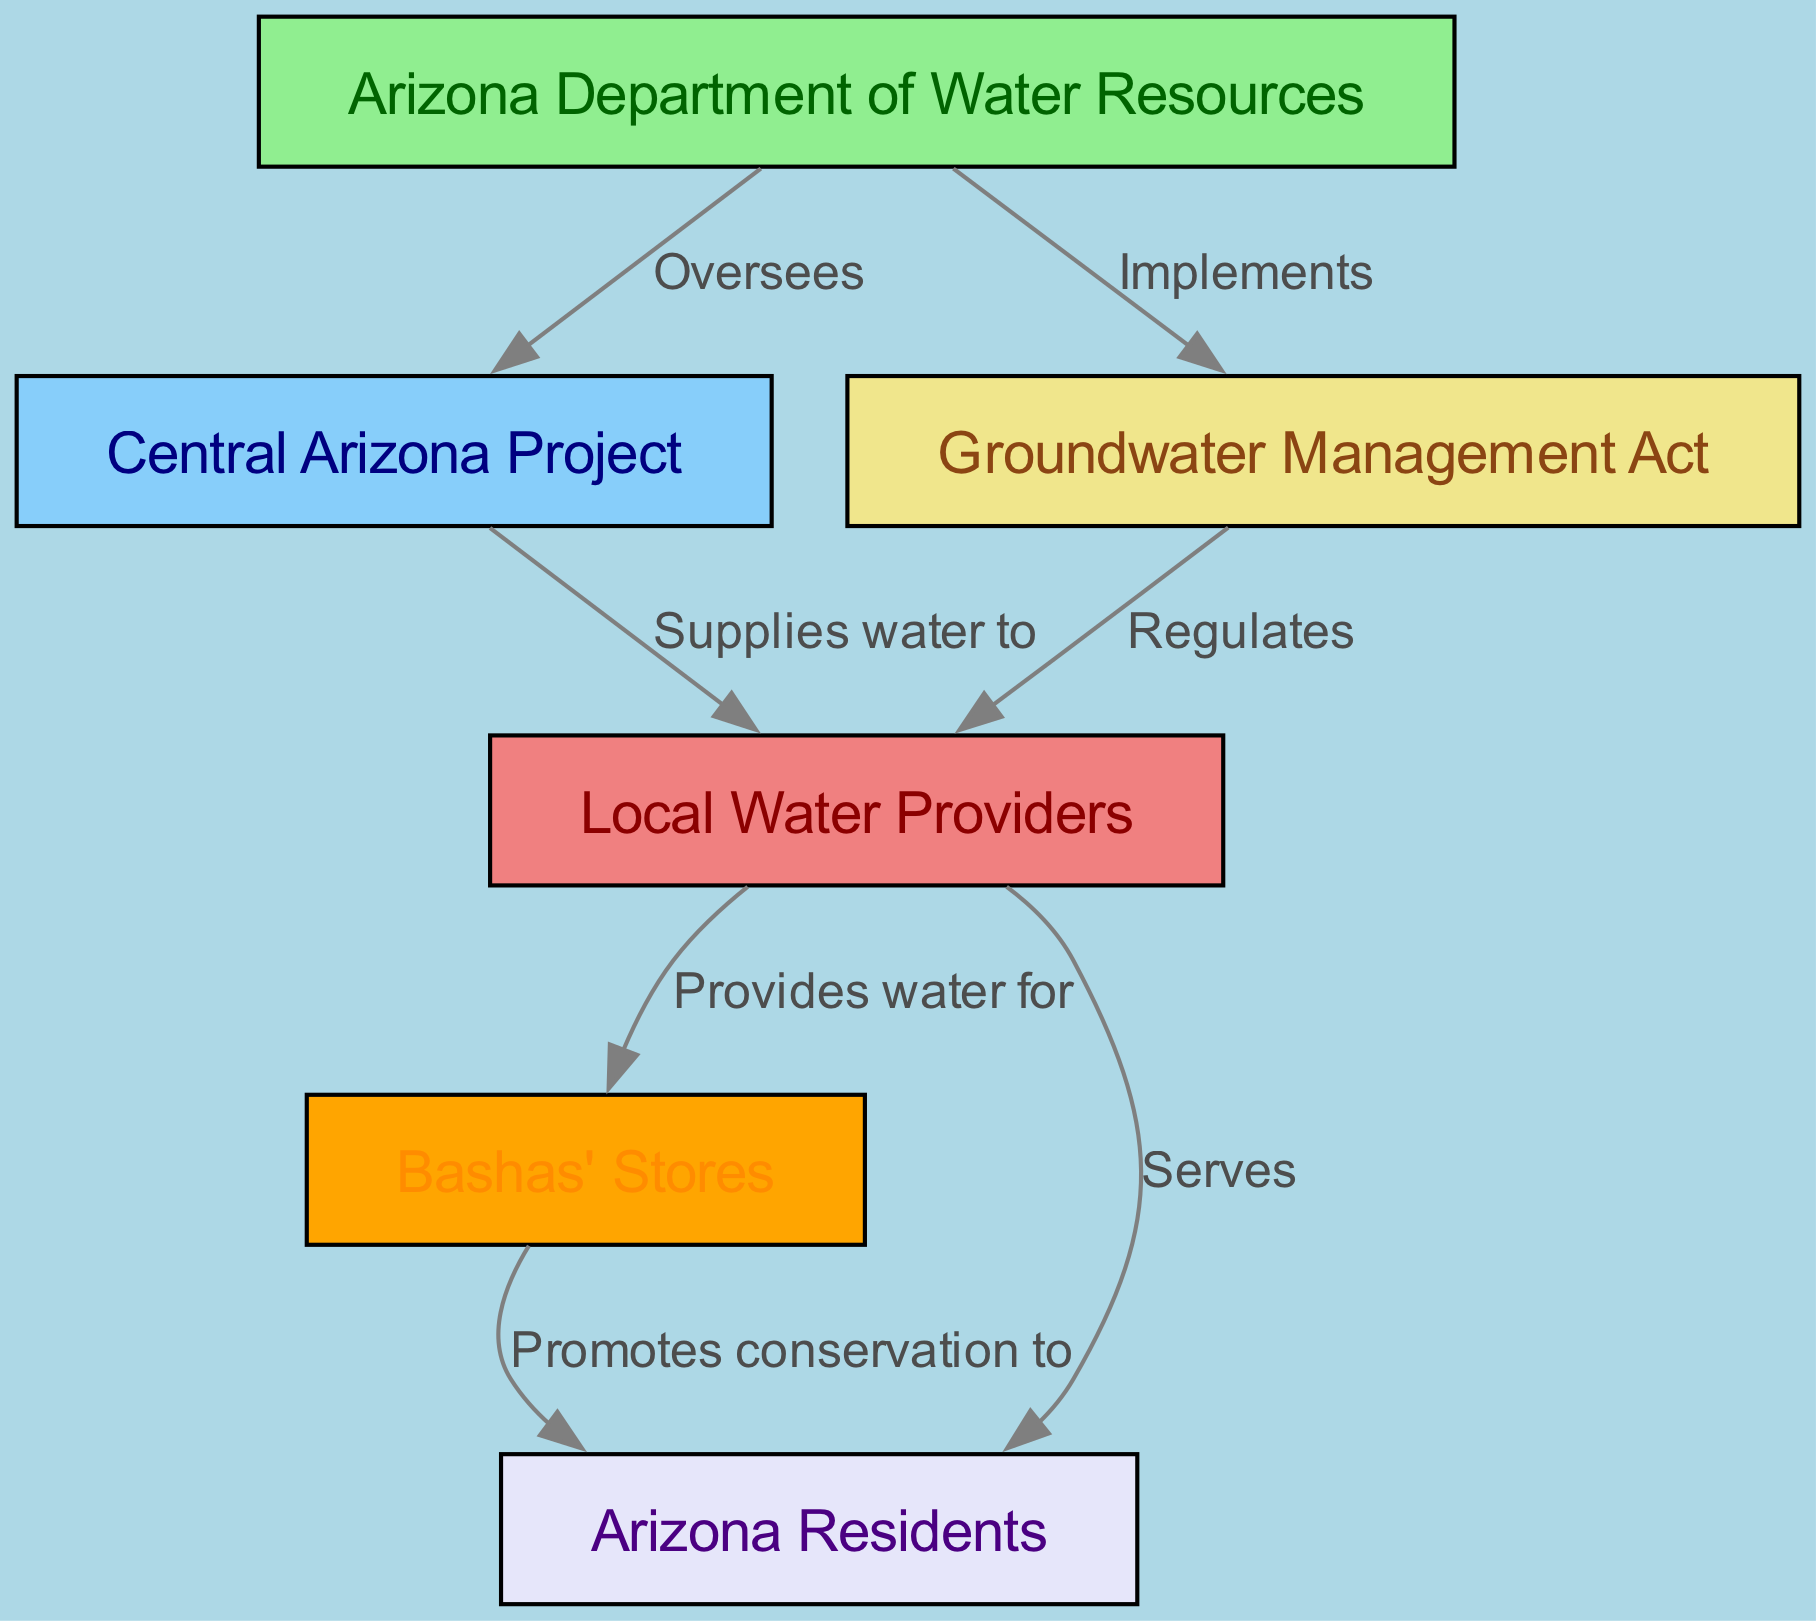What is the total number of nodes in the diagram? The diagram lists the following nodes: Arizona Department of Water Resources, Central Arizona Project, Groundwater Management Act, Local Water Providers, Bashas' Stores, and Arizona Residents. Counting these gives a total of six nodes.
Answer: 6 Which node oversees the Central Arizona Project? The diagram shows an edge from the Arizona Department of Water Resources to the Central Arizona Project labeled "Oversees." This indicates that the Arizona Department of Water Resources is the node responsible for overseeing the Central Arizona Project.
Answer: Arizona Department of Water Resources What label describes the relationship between the Central Arizona Project and Local Water Providers? The edge from the Central Arizona Project to Local Water Providers is labeled "Supplies water to," implying that the Central Arizona Project provides water to local water providers.
Answer: Supplies water to Who promotes conservation to Arizona Residents? According to the diagram, there is an edge from Bashas' Stores to Arizona Residents labeled "Promotes conservation to." This indicates that Bashas' Stores is the entity that promotes water conservation practices to the residents of Arizona.
Answer: Bashas' Stores How many edges are present in the diagram? The diagram has the following edges: Arizona Department of Water Resources to Central Arizona Project, Arizona Department of Water Resources to Groundwater Management Act, Central Arizona Project to Local Water Providers, Groundwater Management Act to Local Water Providers, Local Water Providers to Bashas' Stores, Local Water Providers to Arizona Residents, and Bashas' Stores to Arizona Residents. Counting these gives a total of seven edges.
Answer: 7 Which node is regulated by the Groundwater Management Act? The diagram indicates that the Groundwater Management Act has an edge pointing to Local Water Providers with the label "Regulates." This means that the Local Water Providers are the entities that are regulated by the Groundwater Management Act.
Answer: Local Water Providers What is the impact of Local Water Providers on Bashas' Stores? The edge from Local Water Providers to Bashas' Stores is labeled "Provides water for," indicating that the Local Water Providers supply water for Bashas' Stores, directly impacting their operations.
Answer: Provides water for What is the color associated with Arizona Department of Water Resources in the diagram? The Arizona Department of Water Resources is represented as a green node in the diagram, specifically light green, indicating its supervisory and regulatory role over water resources.
Answer: Light green 